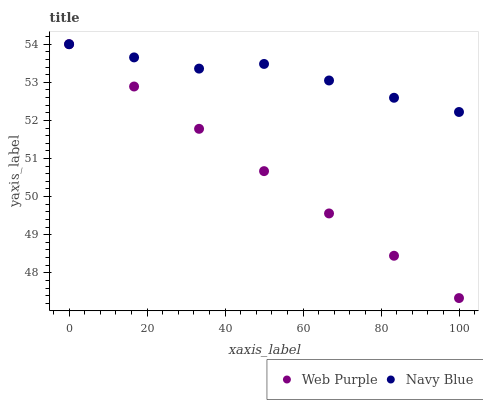Does Web Purple have the minimum area under the curve?
Answer yes or no. Yes. Does Navy Blue have the maximum area under the curve?
Answer yes or no. Yes. Does Web Purple have the maximum area under the curve?
Answer yes or no. No. Is Web Purple the smoothest?
Answer yes or no. Yes. Is Navy Blue the roughest?
Answer yes or no. Yes. Is Web Purple the roughest?
Answer yes or no. No. Does Web Purple have the lowest value?
Answer yes or no. Yes. Does Web Purple have the highest value?
Answer yes or no. Yes. Does Navy Blue intersect Web Purple?
Answer yes or no. Yes. Is Navy Blue less than Web Purple?
Answer yes or no. No. Is Navy Blue greater than Web Purple?
Answer yes or no. No. 